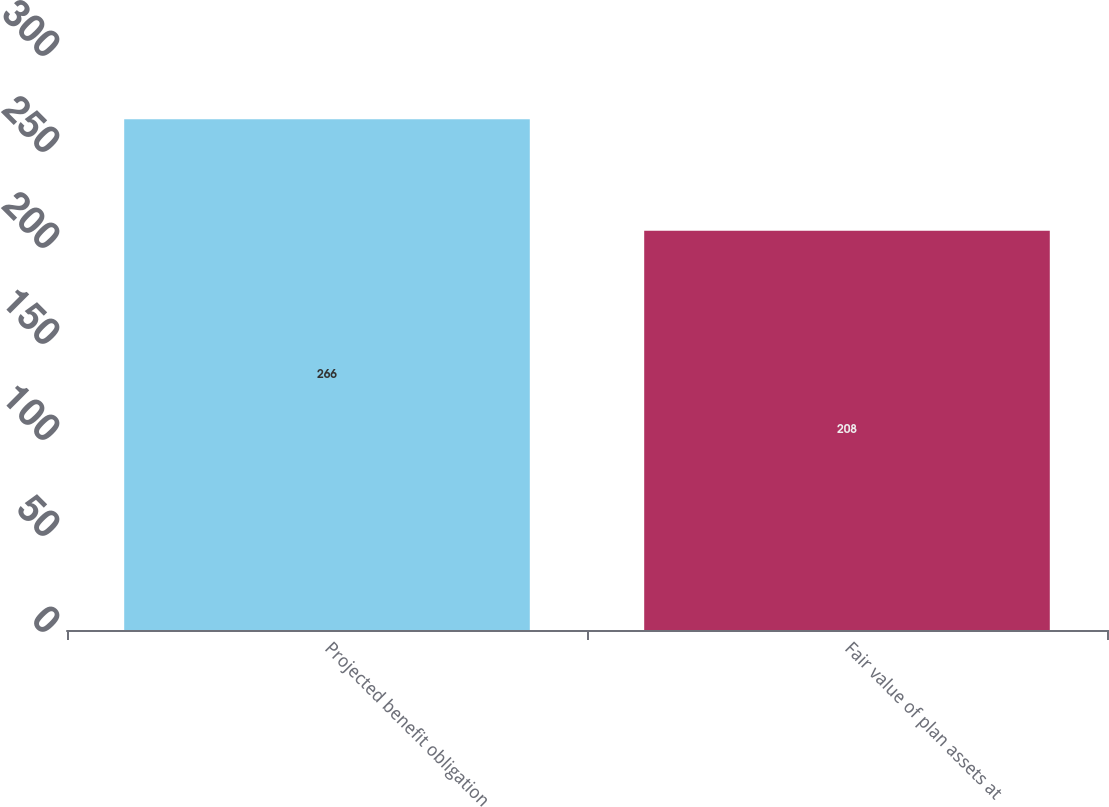<chart> <loc_0><loc_0><loc_500><loc_500><bar_chart><fcel>Projected benefit obligation<fcel>Fair value of plan assets at<nl><fcel>266<fcel>208<nl></chart> 